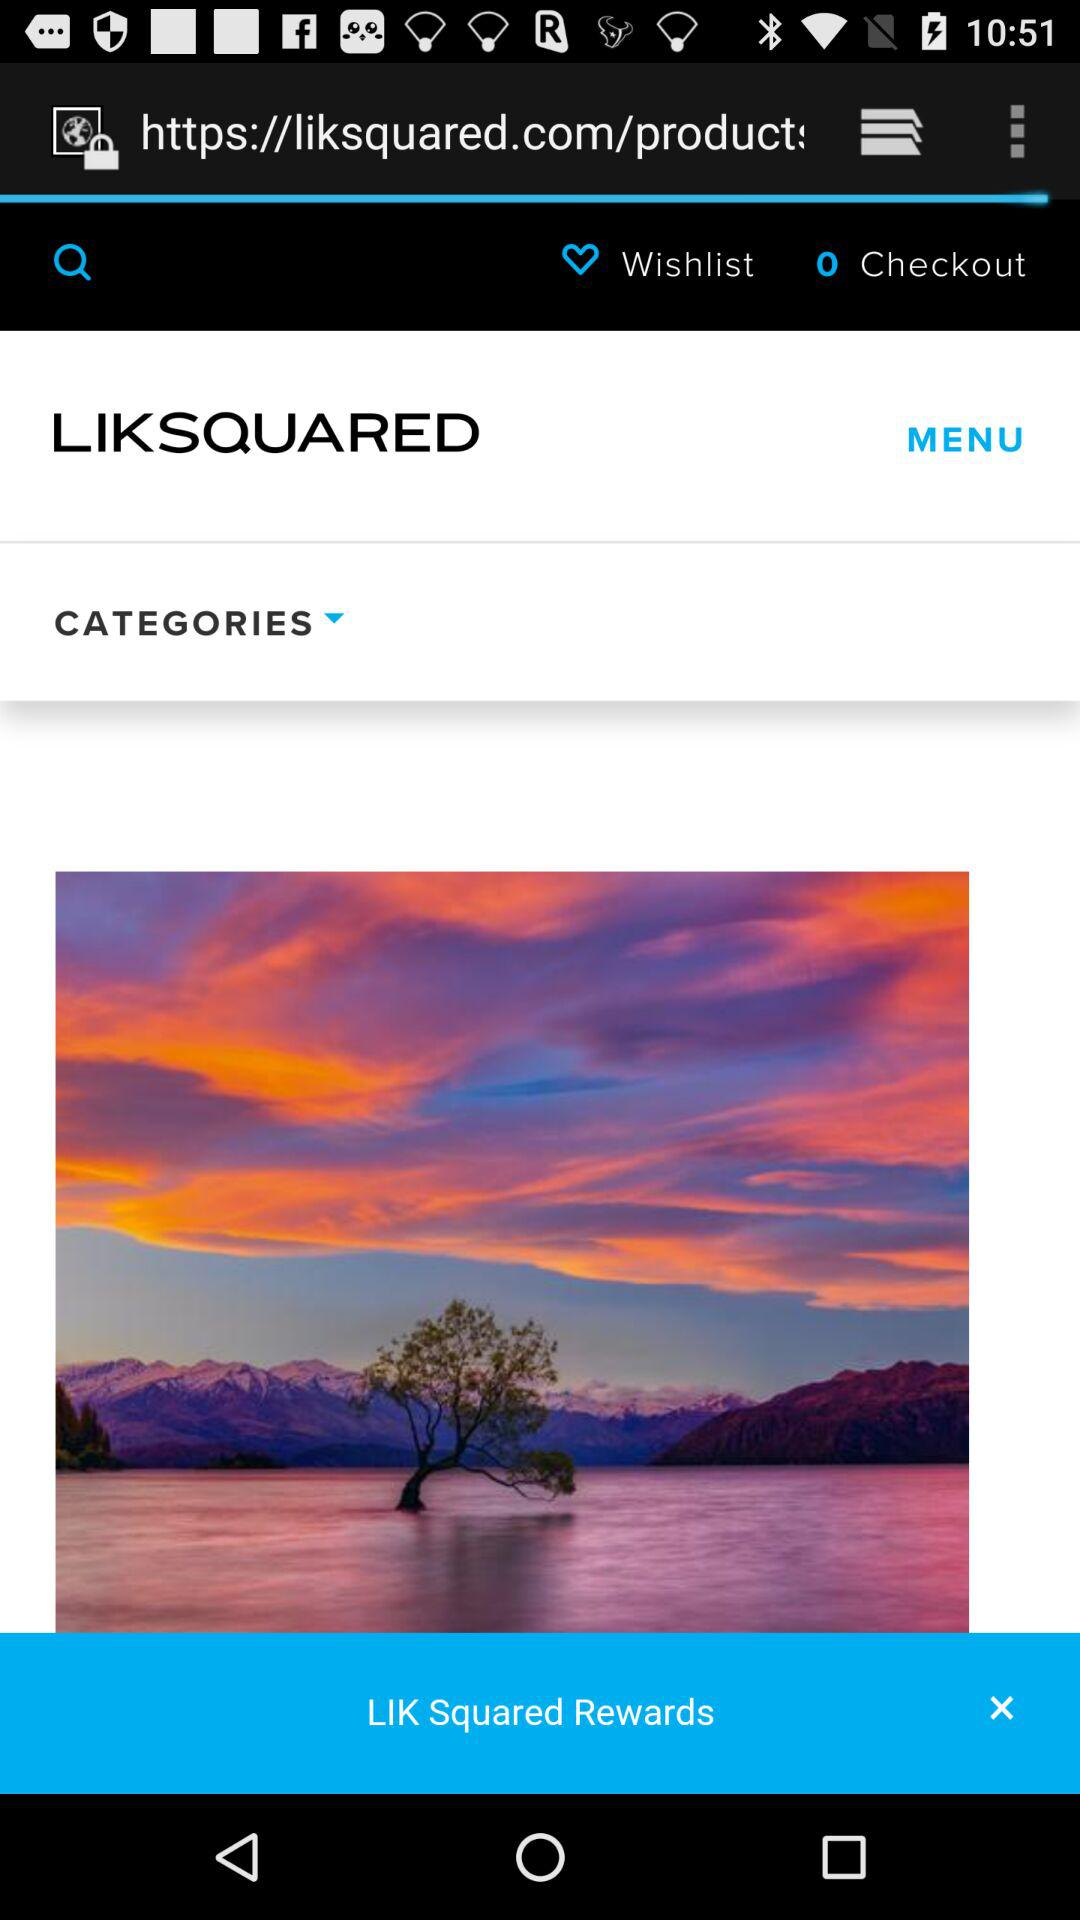How many items are there in checkout? There are 0 items. 